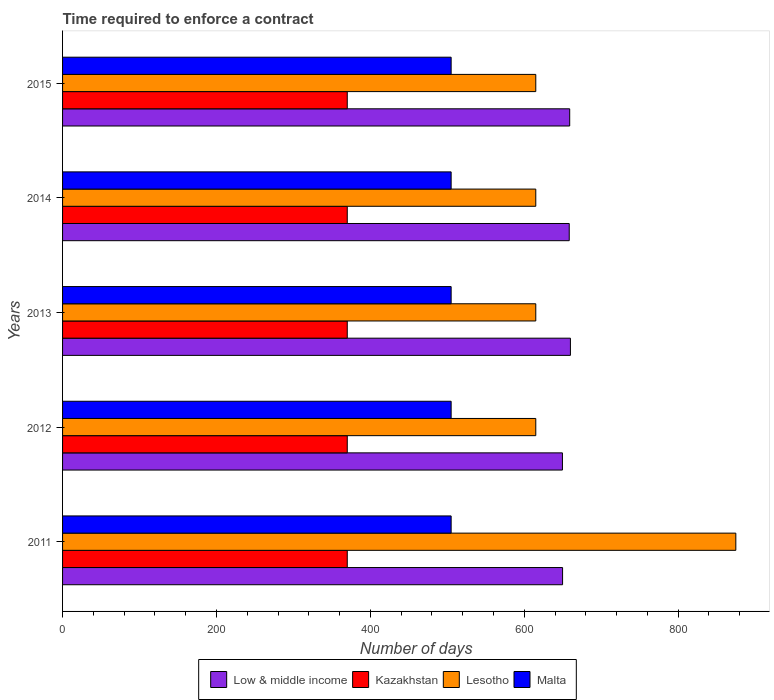How many different coloured bars are there?
Your answer should be compact. 4. Are the number of bars per tick equal to the number of legend labels?
Make the answer very short. Yes. How many bars are there on the 3rd tick from the top?
Give a very brief answer. 4. What is the label of the 2nd group of bars from the top?
Keep it short and to the point. 2014. In how many cases, is the number of bars for a given year not equal to the number of legend labels?
Provide a succinct answer. 0. What is the number of days required to enforce a contract in Lesotho in 2015?
Provide a succinct answer. 615. Across all years, what is the maximum number of days required to enforce a contract in Low & middle income?
Provide a short and direct response. 660.04. Across all years, what is the minimum number of days required to enforce a contract in Low & middle income?
Your answer should be compact. 649.66. In which year was the number of days required to enforce a contract in Malta maximum?
Provide a short and direct response. 2011. What is the total number of days required to enforce a contract in Lesotho in the graph?
Make the answer very short. 3335. What is the difference between the number of days required to enforce a contract in Lesotho in 2011 and that in 2012?
Your answer should be very brief. 260. What is the difference between the number of days required to enforce a contract in Lesotho in 2011 and the number of days required to enforce a contract in Low & middle income in 2015?
Provide a succinct answer. 215.91. What is the average number of days required to enforce a contract in Lesotho per year?
Your answer should be very brief. 667. In the year 2014, what is the difference between the number of days required to enforce a contract in Lesotho and number of days required to enforce a contract in Malta?
Provide a short and direct response. 110. Is the number of days required to enforce a contract in Low & middle income in 2014 less than that in 2015?
Provide a succinct answer. Yes. What is the difference between the highest and the second highest number of days required to enforce a contract in Kazakhstan?
Make the answer very short. 0. What is the difference between the highest and the lowest number of days required to enforce a contract in Lesotho?
Your answer should be very brief. 260. In how many years, is the number of days required to enforce a contract in Malta greater than the average number of days required to enforce a contract in Malta taken over all years?
Make the answer very short. 0. Is the sum of the number of days required to enforce a contract in Malta in 2014 and 2015 greater than the maximum number of days required to enforce a contract in Kazakhstan across all years?
Offer a very short reply. Yes. Is it the case that in every year, the sum of the number of days required to enforce a contract in Malta and number of days required to enforce a contract in Low & middle income is greater than the sum of number of days required to enforce a contract in Kazakhstan and number of days required to enforce a contract in Lesotho?
Your response must be concise. Yes. What does the 2nd bar from the top in 2015 represents?
Your answer should be very brief. Lesotho. What does the 2nd bar from the bottom in 2011 represents?
Offer a terse response. Kazakhstan. Is it the case that in every year, the sum of the number of days required to enforce a contract in Lesotho and number of days required to enforce a contract in Malta is greater than the number of days required to enforce a contract in Low & middle income?
Provide a succinct answer. Yes. How many bars are there?
Offer a very short reply. 20. How many years are there in the graph?
Provide a short and direct response. 5. Are the values on the major ticks of X-axis written in scientific E-notation?
Offer a very short reply. No. Does the graph contain any zero values?
Ensure brevity in your answer.  No. Does the graph contain grids?
Keep it short and to the point. No. How many legend labels are there?
Your answer should be very brief. 4. How are the legend labels stacked?
Provide a short and direct response. Horizontal. What is the title of the graph?
Your response must be concise. Time required to enforce a contract. What is the label or title of the X-axis?
Offer a very short reply. Number of days. What is the Number of days of Low & middle income in 2011?
Your response must be concise. 649.83. What is the Number of days in Kazakhstan in 2011?
Provide a succinct answer. 370. What is the Number of days in Lesotho in 2011?
Your response must be concise. 875. What is the Number of days in Malta in 2011?
Your answer should be very brief. 505. What is the Number of days of Low & middle income in 2012?
Ensure brevity in your answer.  649.66. What is the Number of days of Kazakhstan in 2012?
Your response must be concise. 370. What is the Number of days in Lesotho in 2012?
Offer a very short reply. 615. What is the Number of days in Malta in 2012?
Provide a short and direct response. 505. What is the Number of days in Low & middle income in 2013?
Provide a short and direct response. 660.04. What is the Number of days in Kazakhstan in 2013?
Give a very brief answer. 370. What is the Number of days in Lesotho in 2013?
Offer a terse response. 615. What is the Number of days in Malta in 2013?
Provide a short and direct response. 505. What is the Number of days in Low & middle income in 2014?
Keep it short and to the point. 658.49. What is the Number of days of Kazakhstan in 2014?
Your answer should be very brief. 370. What is the Number of days of Lesotho in 2014?
Provide a succinct answer. 615. What is the Number of days of Malta in 2014?
Keep it short and to the point. 505. What is the Number of days in Low & middle income in 2015?
Offer a very short reply. 659.09. What is the Number of days of Kazakhstan in 2015?
Keep it short and to the point. 370. What is the Number of days of Lesotho in 2015?
Keep it short and to the point. 615. What is the Number of days in Malta in 2015?
Your answer should be very brief. 505. Across all years, what is the maximum Number of days in Low & middle income?
Your response must be concise. 660.04. Across all years, what is the maximum Number of days in Kazakhstan?
Make the answer very short. 370. Across all years, what is the maximum Number of days of Lesotho?
Your answer should be very brief. 875. Across all years, what is the maximum Number of days in Malta?
Your response must be concise. 505. Across all years, what is the minimum Number of days in Low & middle income?
Ensure brevity in your answer.  649.66. Across all years, what is the minimum Number of days of Kazakhstan?
Provide a succinct answer. 370. Across all years, what is the minimum Number of days of Lesotho?
Offer a very short reply. 615. Across all years, what is the minimum Number of days in Malta?
Make the answer very short. 505. What is the total Number of days in Low & middle income in the graph?
Provide a short and direct response. 3277.11. What is the total Number of days of Kazakhstan in the graph?
Keep it short and to the point. 1850. What is the total Number of days in Lesotho in the graph?
Give a very brief answer. 3335. What is the total Number of days of Malta in the graph?
Ensure brevity in your answer.  2525. What is the difference between the Number of days of Low & middle income in 2011 and that in 2012?
Give a very brief answer. 0.17. What is the difference between the Number of days in Kazakhstan in 2011 and that in 2012?
Keep it short and to the point. 0. What is the difference between the Number of days in Lesotho in 2011 and that in 2012?
Provide a short and direct response. 260. What is the difference between the Number of days in Low & middle income in 2011 and that in 2013?
Ensure brevity in your answer.  -10.21. What is the difference between the Number of days of Lesotho in 2011 and that in 2013?
Ensure brevity in your answer.  260. What is the difference between the Number of days of Low & middle income in 2011 and that in 2014?
Your answer should be compact. -8.66. What is the difference between the Number of days of Kazakhstan in 2011 and that in 2014?
Provide a succinct answer. 0. What is the difference between the Number of days of Lesotho in 2011 and that in 2014?
Provide a succinct answer. 260. What is the difference between the Number of days in Malta in 2011 and that in 2014?
Offer a very short reply. 0. What is the difference between the Number of days in Low & middle income in 2011 and that in 2015?
Make the answer very short. -9.26. What is the difference between the Number of days of Lesotho in 2011 and that in 2015?
Your answer should be compact. 260. What is the difference between the Number of days in Malta in 2011 and that in 2015?
Give a very brief answer. 0. What is the difference between the Number of days of Low & middle income in 2012 and that in 2013?
Your response must be concise. -10.38. What is the difference between the Number of days in Lesotho in 2012 and that in 2013?
Make the answer very short. 0. What is the difference between the Number of days in Low & middle income in 2012 and that in 2014?
Make the answer very short. -8.83. What is the difference between the Number of days of Malta in 2012 and that in 2014?
Your answer should be very brief. 0. What is the difference between the Number of days in Low & middle income in 2012 and that in 2015?
Provide a short and direct response. -9.43. What is the difference between the Number of days in Malta in 2012 and that in 2015?
Provide a short and direct response. 0. What is the difference between the Number of days of Low & middle income in 2013 and that in 2014?
Offer a very short reply. 1.55. What is the difference between the Number of days of Low & middle income in 2013 and that in 2015?
Make the answer very short. 0.95. What is the difference between the Number of days in Kazakhstan in 2013 and that in 2015?
Give a very brief answer. 0. What is the difference between the Number of days of Malta in 2013 and that in 2015?
Make the answer very short. 0. What is the difference between the Number of days in Low & middle income in 2014 and that in 2015?
Your answer should be compact. -0.6. What is the difference between the Number of days in Kazakhstan in 2014 and that in 2015?
Your response must be concise. 0. What is the difference between the Number of days in Lesotho in 2014 and that in 2015?
Ensure brevity in your answer.  0. What is the difference between the Number of days in Malta in 2014 and that in 2015?
Keep it short and to the point. 0. What is the difference between the Number of days in Low & middle income in 2011 and the Number of days in Kazakhstan in 2012?
Your response must be concise. 279.83. What is the difference between the Number of days of Low & middle income in 2011 and the Number of days of Lesotho in 2012?
Your answer should be very brief. 34.83. What is the difference between the Number of days of Low & middle income in 2011 and the Number of days of Malta in 2012?
Offer a very short reply. 144.83. What is the difference between the Number of days in Kazakhstan in 2011 and the Number of days in Lesotho in 2012?
Offer a very short reply. -245. What is the difference between the Number of days of Kazakhstan in 2011 and the Number of days of Malta in 2012?
Your answer should be very brief. -135. What is the difference between the Number of days of Lesotho in 2011 and the Number of days of Malta in 2012?
Make the answer very short. 370. What is the difference between the Number of days in Low & middle income in 2011 and the Number of days in Kazakhstan in 2013?
Offer a very short reply. 279.83. What is the difference between the Number of days of Low & middle income in 2011 and the Number of days of Lesotho in 2013?
Provide a succinct answer. 34.83. What is the difference between the Number of days of Low & middle income in 2011 and the Number of days of Malta in 2013?
Give a very brief answer. 144.83. What is the difference between the Number of days of Kazakhstan in 2011 and the Number of days of Lesotho in 2013?
Your answer should be compact. -245. What is the difference between the Number of days in Kazakhstan in 2011 and the Number of days in Malta in 2013?
Your answer should be very brief. -135. What is the difference between the Number of days of Lesotho in 2011 and the Number of days of Malta in 2013?
Your answer should be compact. 370. What is the difference between the Number of days in Low & middle income in 2011 and the Number of days in Kazakhstan in 2014?
Keep it short and to the point. 279.83. What is the difference between the Number of days of Low & middle income in 2011 and the Number of days of Lesotho in 2014?
Offer a terse response. 34.83. What is the difference between the Number of days of Low & middle income in 2011 and the Number of days of Malta in 2014?
Your response must be concise. 144.83. What is the difference between the Number of days in Kazakhstan in 2011 and the Number of days in Lesotho in 2014?
Offer a very short reply. -245. What is the difference between the Number of days in Kazakhstan in 2011 and the Number of days in Malta in 2014?
Your answer should be very brief. -135. What is the difference between the Number of days in Lesotho in 2011 and the Number of days in Malta in 2014?
Keep it short and to the point. 370. What is the difference between the Number of days of Low & middle income in 2011 and the Number of days of Kazakhstan in 2015?
Ensure brevity in your answer.  279.83. What is the difference between the Number of days of Low & middle income in 2011 and the Number of days of Lesotho in 2015?
Make the answer very short. 34.83. What is the difference between the Number of days of Low & middle income in 2011 and the Number of days of Malta in 2015?
Offer a very short reply. 144.83. What is the difference between the Number of days in Kazakhstan in 2011 and the Number of days in Lesotho in 2015?
Keep it short and to the point. -245. What is the difference between the Number of days of Kazakhstan in 2011 and the Number of days of Malta in 2015?
Keep it short and to the point. -135. What is the difference between the Number of days in Lesotho in 2011 and the Number of days in Malta in 2015?
Your answer should be compact. 370. What is the difference between the Number of days in Low & middle income in 2012 and the Number of days in Kazakhstan in 2013?
Provide a short and direct response. 279.66. What is the difference between the Number of days of Low & middle income in 2012 and the Number of days of Lesotho in 2013?
Ensure brevity in your answer.  34.66. What is the difference between the Number of days of Low & middle income in 2012 and the Number of days of Malta in 2013?
Offer a terse response. 144.66. What is the difference between the Number of days in Kazakhstan in 2012 and the Number of days in Lesotho in 2013?
Offer a very short reply. -245. What is the difference between the Number of days in Kazakhstan in 2012 and the Number of days in Malta in 2013?
Provide a short and direct response. -135. What is the difference between the Number of days of Lesotho in 2012 and the Number of days of Malta in 2013?
Give a very brief answer. 110. What is the difference between the Number of days in Low & middle income in 2012 and the Number of days in Kazakhstan in 2014?
Provide a succinct answer. 279.66. What is the difference between the Number of days in Low & middle income in 2012 and the Number of days in Lesotho in 2014?
Ensure brevity in your answer.  34.66. What is the difference between the Number of days in Low & middle income in 2012 and the Number of days in Malta in 2014?
Offer a terse response. 144.66. What is the difference between the Number of days of Kazakhstan in 2012 and the Number of days of Lesotho in 2014?
Provide a short and direct response. -245. What is the difference between the Number of days in Kazakhstan in 2012 and the Number of days in Malta in 2014?
Your answer should be compact. -135. What is the difference between the Number of days of Lesotho in 2012 and the Number of days of Malta in 2014?
Provide a short and direct response. 110. What is the difference between the Number of days in Low & middle income in 2012 and the Number of days in Kazakhstan in 2015?
Provide a short and direct response. 279.66. What is the difference between the Number of days of Low & middle income in 2012 and the Number of days of Lesotho in 2015?
Your response must be concise. 34.66. What is the difference between the Number of days in Low & middle income in 2012 and the Number of days in Malta in 2015?
Your response must be concise. 144.66. What is the difference between the Number of days in Kazakhstan in 2012 and the Number of days in Lesotho in 2015?
Your answer should be very brief. -245. What is the difference between the Number of days of Kazakhstan in 2012 and the Number of days of Malta in 2015?
Make the answer very short. -135. What is the difference between the Number of days in Lesotho in 2012 and the Number of days in Malta in 2015?
Keep it short and to the point. 110. What is the difference between the Number of days in Low & middle income in 2013 and the Number of days in Kazakhstan in 2014?
Give a very brief answer. 290.04. What is the difference between the Number of days in Low & middle income in 2013 and the Number of days in Lesotho in 2014?
Your response must be concise. 45.04. What is the difference between the Number of days of Low & middle income in 2013 and the Number of days of Malta in 2014?
Provide a succinct answer. 155.04. What is the difference between the Number of days of Kazakhstan in 2013 and the Number of days of Lesotho in 2014?
Your answer should be very brief. -245. What is the difference between the Number of days of Kazakhstan in 2013 and the Number of days of Malta in 2014?
Provide a succinct answer. -135. What is the difference between the Number of days of Lesotho in 2013 and the Number of days of Malta in 2014?
Keep it short and to the point. 110. What is the difference between the Number of days in Low & middle income in 2013 and the Number of days in Kazakhstan in 2015?
Offer a very short reply. 290.04. What is the difference between the Number of days in Low & middle income in 2013 and the Number of days in Lesotho in 2015?
Offer a terse response. 45.04. What is the difference between the Number of days in Low & middle income in 2013 and the Number of days in Malta in 2015?
Offer a terse response. 155.04. What is the difference between the Number of days in Kazakhstan in 2013 and the Number of days in Lesotho in 2015?
Keep it short and to the point. -245. What is the difference between the Number of days in Kazakhstan in 2013 and the Number of days in Malta in 2015?
Your response must be concise. -135. What is the difference between the Number of days of Lesotho in 2013 and the Number of days of Malta in 2015?
Ensure brevity in your answer.  110. What is the difference between the Number of days of Low & middle income in 2014 and the Number of days of Kazakhstan in 2015?
Your response must be concise. 288.49. What is the difference between the Number of days in Low & middle income in 2014 and the Number of days in Lesotho in 2015?
Offer a very short reply. 43.49. What is the difference between the Number of days in Low & middle income in 2014 and the Number of days in Malta in 2015?
Ensure brevity in your answer.  153.49. What is the difference between the Number of days in Kazakhstan in 2014 and the Number of days in Lesotho in 2015?
Offer a very short reply. -245. What is the difference between the Number of days in Kazakhstan in 2014 and the Number of days in Malta in 2015?
Provide a short and direct response. -135. What is the difference between the Number of days in Lesotho in 2014 and the Number of days in Malta in 2015?
Your answer should be compact. 110. What is the average Number of days in Low & middle income per year?
Offer a terse response. 655.42. What is the average Number of days in Kazakhstan per year?
Offer a terse response. 370. What is the average Number of days of Lesotho per year?
Ensure brevity in your answer.  667. What is the average Number of days of Malta per year?
Make the answer very short. 505. In the year 2011, what is the difference between the Number of days in Low & middle income and Number of days in Kazakhstan?
Your answer should be very brief. 279.83. In the year 2011, what is the difference between the Number of days of Low & middle income and Number of days of Lesotho?
Make the answer very short. -225.17. In the year 2011, what is the difference between the Number of days of Low & middle income and Number of days of Malta?
Keep it short and to the point. 144.83. In the year 2011, what is the difference between the Number of days in Kazakhstan and Number of days in Lesotho?
Your answer should be very brief. -505. In the year 2011, what is the difference between the Number of days in Kazakhstan and Number of days in Malta?
Keep it short and to the point. -135. In the year 2011, what is the difference between the Number of days of Lesotho and Number of days of Malta?
Provide a short and direct response. 370. In the year 2012, what is the difference between the Number of days in Low & middle income and Number of days in Kazakhstan?
Your answer should be compact. 279.66. In the year 2012, what is the difference between the Number of days of Low & middle income and Number of days of Lesotho?
Ensure brevity in your answer.  34.66. In the year 2012, what is the difference between the Number of days in Low & middle income and Number of days in Malta?
Keep it short and to the point. 144.66. In the year 2012, what is the difference between the Number of days in Kazakhstan and Number of days in Lesotho?
Offer a terse response. -245. In the year 2012, what is the difference between the Number of days of Kazakhstan and Number of days of Malta?
Offer a terse response. -135. In the year 2012, what is the difference between the Number of days in Lesotho and Number of days in Malta?
Provide a succinct answer. 110. In the year 2013, what is the difference between the Number of days of Low & middle income and Number of days of Kazakhstan?
Your response must be concise. 290.04. In the year 2013, what is the difference between the Number of days in Low & middle income and Number of days in Lesotho?
Give a very brief answer. 45.04. In the year 2013, what is the difference between the Number of days of Low & middle income and Number of days of Malta?
Offer a terse response. 155.04. In the year 2013, what is the difference between the Number of days of Kazakhstan and Number of days of Lesotho?
Offer a very short reply. -245. In the year 2013, what is the difference between the Number of days of Kazakhstan and Number of days of Malta?
Your response must be concise. -135. In the year 2013, what is the difference between the Number of days of Lesotho and Number of days of Malta?
Your response must be concise. 110. In the year 2014, what is the difference between the Number of days of Low & middle income and Number of days of Kazakhstan?
Keep it short and to the point. 288.49. In the year 2014, what is the difference between the Number of days of Low & middle income and Number of days of Lesotho?
Your answer should be very brief. 43.49. In the year 2014, what is the difference between the Number of days of Low & middle income and Number of days of Malta?
Give a very brief answer. 153.49. In the year 2014, what is the difference between the Number of days of Kazakhstan and Number of days of Lesotho?
Your response must be concise. -245. In the year 2014, what is the difference between the Number of days in Kazakhstan and Number of days in Malta?
Keep it short and to the point. -135. In the year 2014, what is the difference between the Number of days of Lesotho and Number of days of Malta?
Your response must be concise. 110. In the year 2015, what is the difference between the Number of days in Low & middle income and Number of days in Kazakhstan?
Make the answer very short. 289.09. In the year 2015, what is the difference between the Number of days in Low & middle income and Number of days in Lesotho?
Your answer should be very brief. 44.09. In the year 2015, what is the difference between the Number of days of Low & middle income and Number of days of Malta?
Make the answer very short. 154.09. In the year 2015, what is the difference between the Number of days of Kazakhstan and Number of days of Lesotho?
Your answer should be very brief. -245. In the year 2015, what is the difference between the Number of days of Kazakhstan and Number of days of Malta?
Your response must be concise. -135. In the year 2015, what is the difference between the Number of days of Lesotho and Number of days of Malta?
Offer a very short reply. 110. What is the ratio of the Number of days of Lesotho in 2011 to that in 2012?
Offer a very short reply. 1.42. What is the ratio of the Number of days of Malta in 2011 to that in 2012?
Provide a short and direct response. 1. What is the ratio of the Number of days of Low & middle income in 2011 to that in 2013?
Keep it short and to the point. 0.98. What is the ratio of the Number of days in Lesotho in 2011 to that in 2013?
Your answer should be compact. 1.42. What is the ratio of the Number of days of Low & middle income in 2011 to that in 2014?
Ensure brevity in your answer.  0.99. What is the ratio of the Number of days in Lesotho in 2011 to that in 2014?
Your answer should be very brief. 1.42. What is the ratio of the Number of days in Low & middle income in 2011 to that in 2015?
Give a very brief answer. 0.99. What is the ratio of the Number of days in Lesotho in 2011 to that in 2015?
Give a very brief answer. 1.42. What is the ratio of the Number of days of Malta in 2011 to that in 2015?
Provide a short and direct response. 1. What is the ratio of the Number of days of Low & middle income in 2012 to that in 2013?
Provide a short and direct response. 0.98. What is the ratio of the Number of days of Lesotho in 2012 to that in 2013?
Provide a succinct answer. 1. What is the ratio of the Number of days in Low & middle income in 2012 to that in 2014?
Give a very brief answer. 0.99. What is the ratio of the Number of days of Kazakhstan in 2012 to that in 2014?
Give a very brief answer. 1. What is the ratio of the Number of days of Malta in 2012 to that in 2014?
Offer a very short reply. 1. What is the ratio of the Number of days in Low & middle income in 2012 to that in 2015?
Your response must be concise. 0.99. What is the ratio of the Number of days of Kazakhstan in 2012 to that in 2015?
Make the answer very short. 1. What is the ratio of the Number of days of Lesotho in 2012 to that in 2015?
Make the answer very short. 1. What is the ratio of the Number of days of Kazakhstan in 2013 to that in 2014?
Your answer should be very brief. 1. What is the ratio of the Number of days of Low & middle income in 2013 to that in 2015?
Ensure brevity in your answer.  1. What is the ratio of the Number of days of Kazakhstan in 2013 to that in 2015?
Give a very brief answer. 1. What is the ratio of the Number of days in Lesotho in 2013 to that in 2015?
Give a very brief answer. 1. What is the ratio of the Number of days of Lesotho in 2014 to that in 2015?
Your response must be concise. 1. What is the ratio of the Number of days of Malta in 2014 to that in 2015?
Your response must be concise. 1. What is the difference between the highest and the second highest Number of days in Low & middle income?
Ensure brevity in your answer.  0.95. What is the difference between the highest and the second highest Number of days in Kazakhstan?
Keep it short and to the point. 0. What is the difference between the highest and the second highest Number of days in Lesotho?
Offer a terse response. 260. What is the difference between the highest and the lowest Number of days of Low & middle income?
Offer a very short reply. 10.38. What is the difference between the highest and the lowest Number of days of Kazakhstan?
Your answer should be very brief. 0. What is the difference between the highest and the lowest Number of days of Lesotho?
Offer a very short reply. 260. 